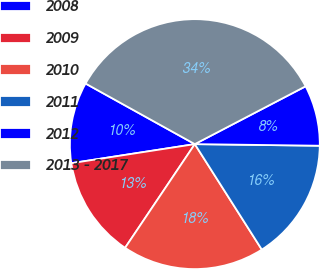<chart> <loc_0><loc_0><loc_500><loc_500><pie_chart><fcel>2008<fcel>2009<fcel>2010<fcel>2011<fcel>2012<fcel>2013 - 2017<nl><fcel>10.5%<fcel>13.14%<fcel>18.43%<fcel>15.79%<fcel>7.86%<fcel>34.29%<nl></chart> 